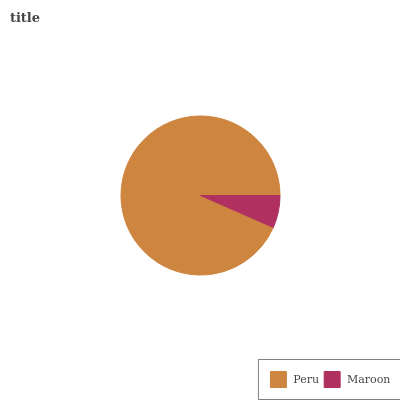Is Maroon the minimum?
Answer yes or no. Yes. Is Peru the maximum?
Answer yes or no. Yes. Is Maroon the maximum?
Answer yes or no. No. Is Peru greater than Maroon?
Answer yes or no. Yes. Is Maroon less than Peru?
Answer yes or no. Yes. Is Maroon greater than Peru?
Answer yes or no. No. Is Peru less than Maroon?
Answer yes or no. No. Is Peru the high median?
Answer yes or no. Yes. Is Maroon the low median?
Answer yes or no. Yes. Is Maroon the high median?
Answer yes or no. No. Is Peru the low median?
Answer yes or no. No. 